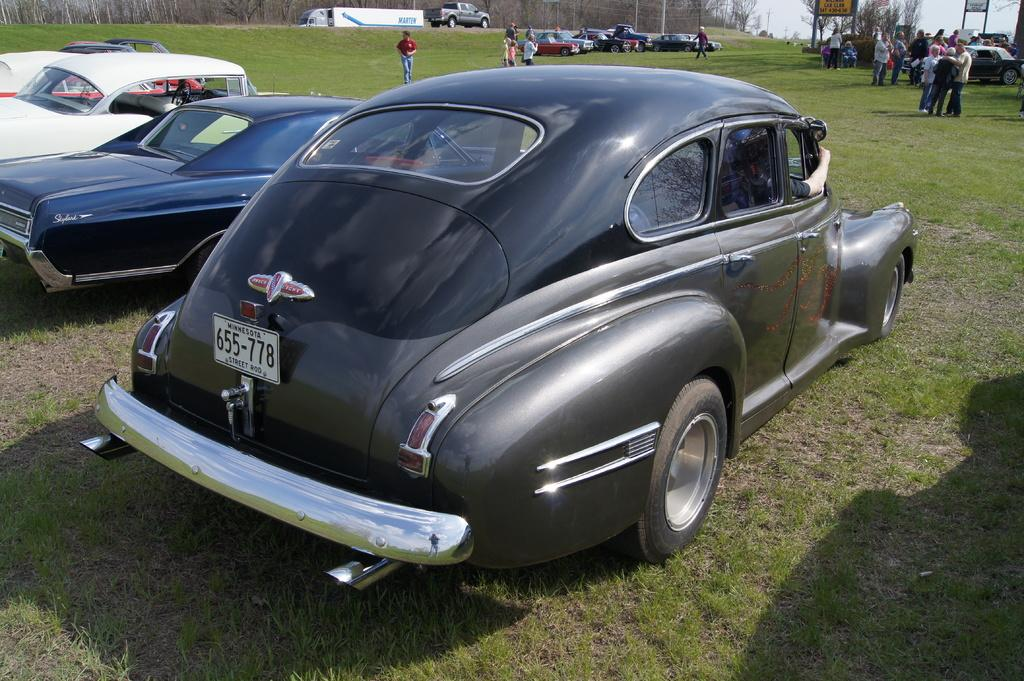What type of vehicles are in the image? There are cars in the image. Where are the cars located? The cars are on the ground. Who else is present in the image besides the cars? There are people in the image. What are the people doing in the image? The people are standing on the ground. What type of milk can be seen in the image? There is no milk present in the image. How many eyes can be seen on the cars in the image? Cars do not have eyes, so this question cannot be answered based on the image. 